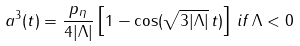Convert formula to latex. <formula><loc_0><loc_0><loc_500><loc_500>a ^ { 3 } ( t ) = \frac { p _ { \eta } } { 4 | \Lambda | } \left [ 1 - \cos ( \sqrt { 3 | \Lambda | } \, t ) \right ] \, i f \, \Lambda < 0</formula> 